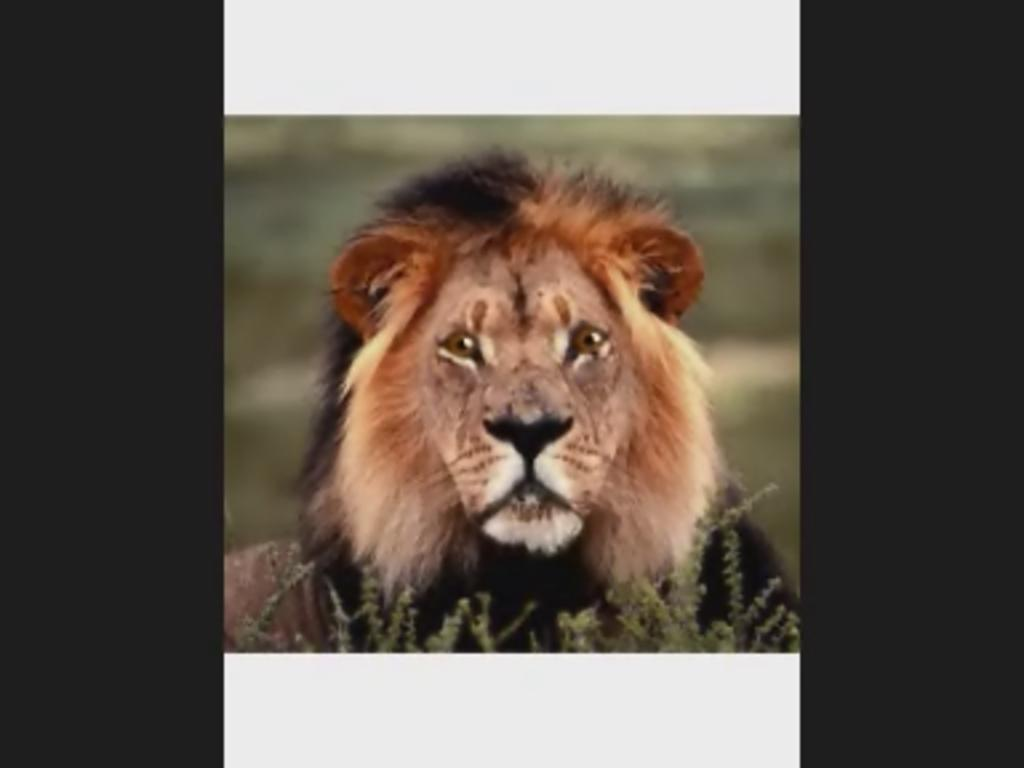What animal is the main subject of the image? There is a lion in the image. Can you describe the background of the image? The background of the image is blurred. What type of grape is being polished in the image? There is no grape or polishing activity present in the image; it features a lion with a blurred background. 